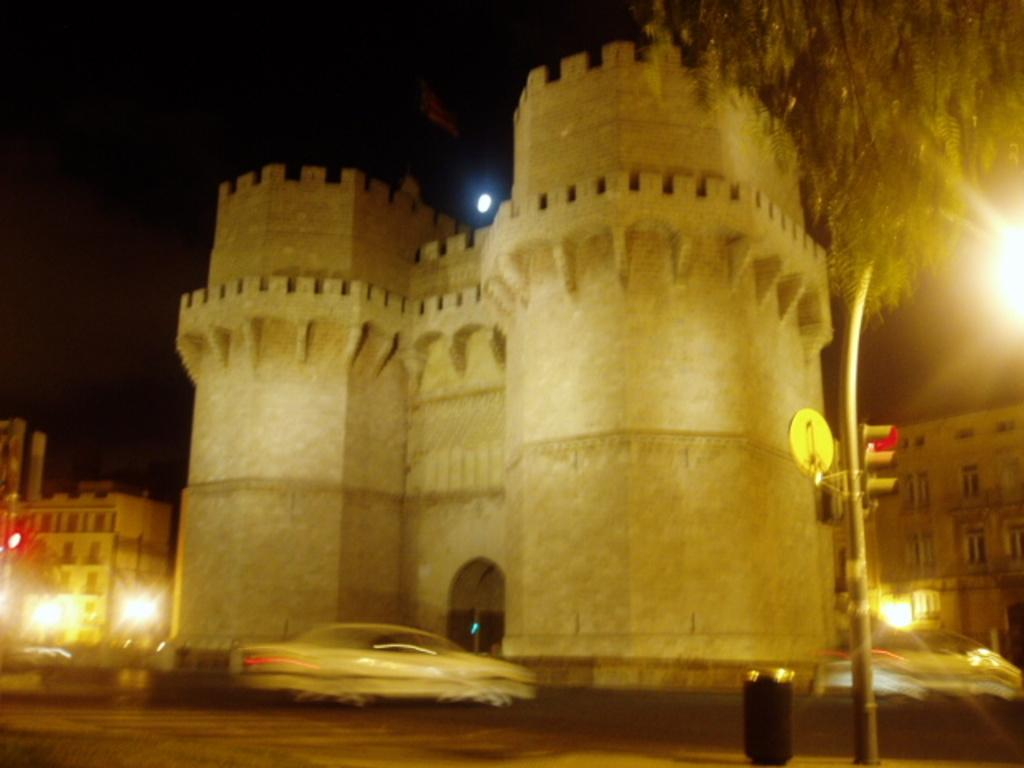What type of construction is depicted in the image? There is a construction in the shape of a fort in the image. What can be seen on the right side of the image? There is a traffic signal on the right side of the image. What is located at the top of the image? There is a tree at the top of the image. What is visible in the background of the image? The sky is visible at the top of the image. What type of lettuce is growing on the tree in the image? There is no lettuce present in the image; it features a tree without any plants or produce. 